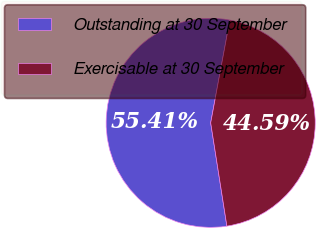Convert chart. <chart><loc_0><loc_0><loc_500><loc_500><pie_chart><fcel>Outstanding at 30 September<fcel>Exercisable at 30 September<nl><fcel>55.41%<fcel>44.59%<nl></chart> 